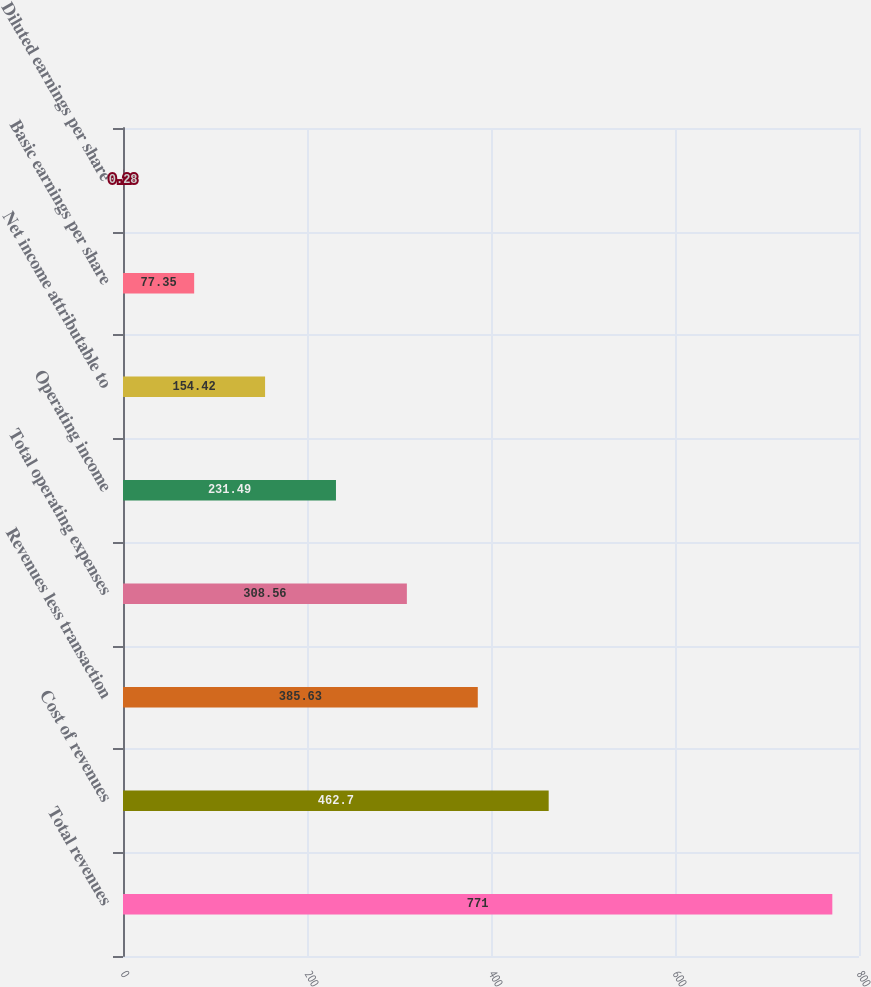Convert chart to OTSL. <chart><loc_0><loc_0><loc_500><loc_500><bar_chart><fcel>Total revenues<fcel>Cost of revenues<fcel>Revenues less transaction<fcel>Total operating expenses<fcel>Operating income<fcel>Net income attributable to<fcel>Basic earnings per share<fcel>Diluted earnings per share<nl><fcel>771<fcel>462.7<fcel>385.63<fcel>308.56<fcel>231.49<fcel>154.42<fcel>77.35<fcel>0.28<nl></chart> 